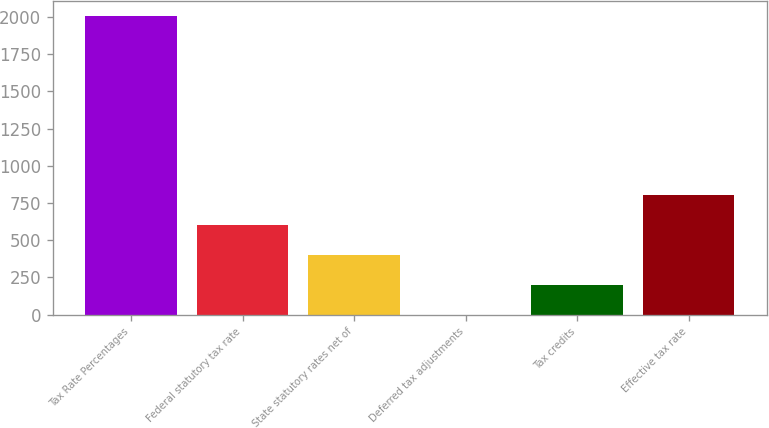Convert chart to OTSL. <chart><loc_0><loc_0><loc_500><loc_500><bar_chart><fcel>Tax Rate Percentages<fcel>Federal statutory tax rate<fcel>State statutory rates net of<fcel>Deferred tax adjustments<fcel>Tax credits<fcel>Effective tax rate<nl><fcel>2008<fcel>602.89<fcel>402.16<fcel>0.7<fcel>201.43<fcel>803.62<nl></chart> 